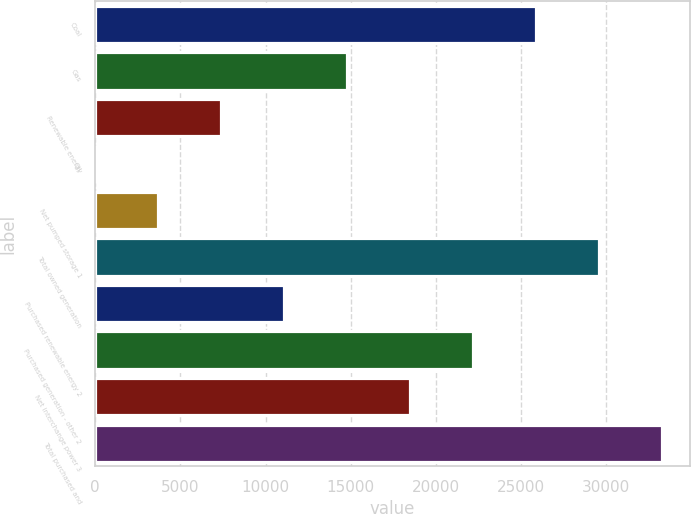Convert chart to OTSL. <chart><loc_0><loc_0><loc_500><loc_500><bar_chart><fcel>Coal<fcel>Gas<fcel>Renewable energy<fcel>Oil<fcel>Net pumped storage 1<fcel>Total owned generation<fcel>Purchased renewable energy 2<fcel>Purchased generation - other 2<fcel>Net interchange power 3<fcel>Total purchased and<nl><fcel>25864.3<fcel>14782.6<fcel>7394.8<fcel>7<fcel>3700.9<fcel>29558.2<fcel>11088.7<fcel>22170.4<fcel>18476.5<fcel>33252.1<nl></chart> 